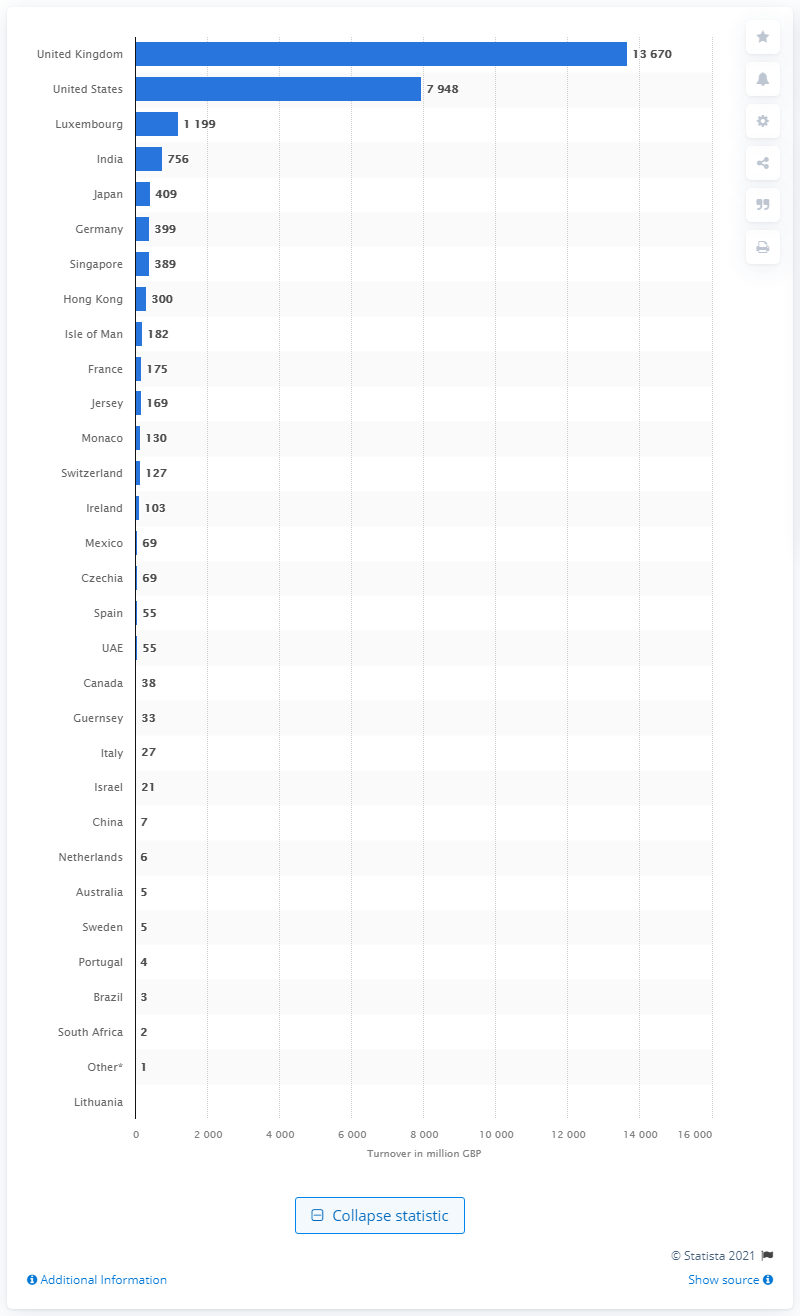List a handful of essential elements in this visual. In 2020, the total revenue of British Barclays Group in the UK was 13,670. As of 2020, the United States generated approximately 7,948 British pounds in revenue. 